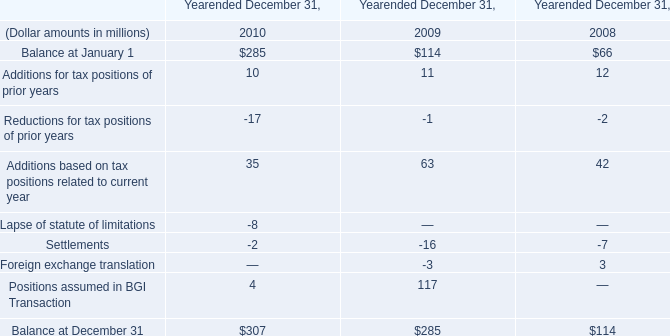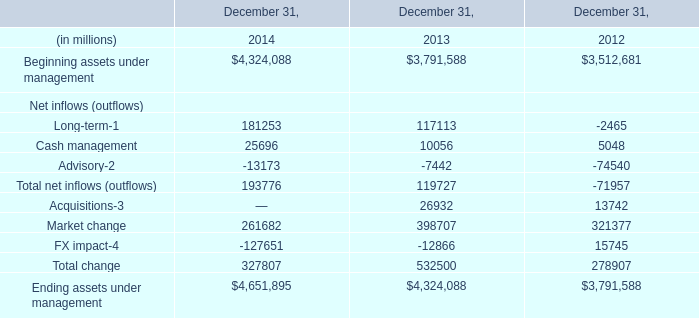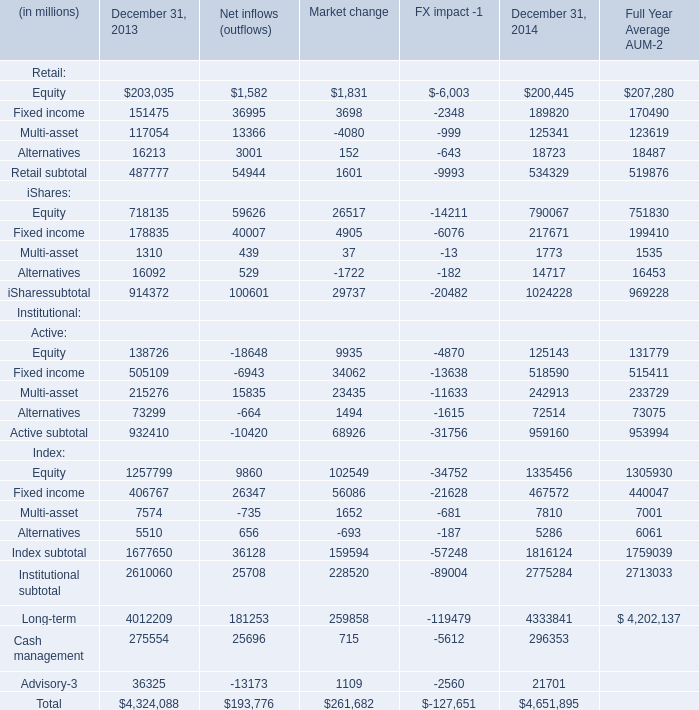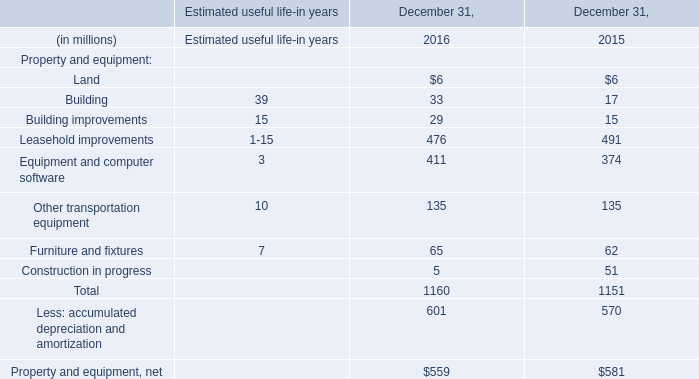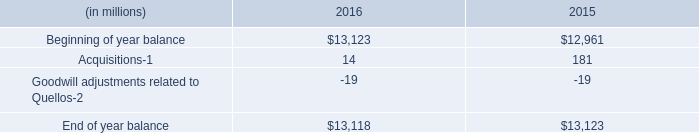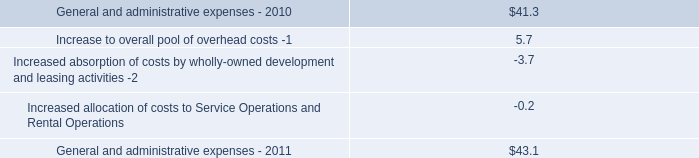What will Fixed income be like in 2015 if it develops with the same increasing rate as current? (in million) 
Computations: ((((189820 - 151475) / 151475) + 1) * 189820)
Answer: 237871.80987. 